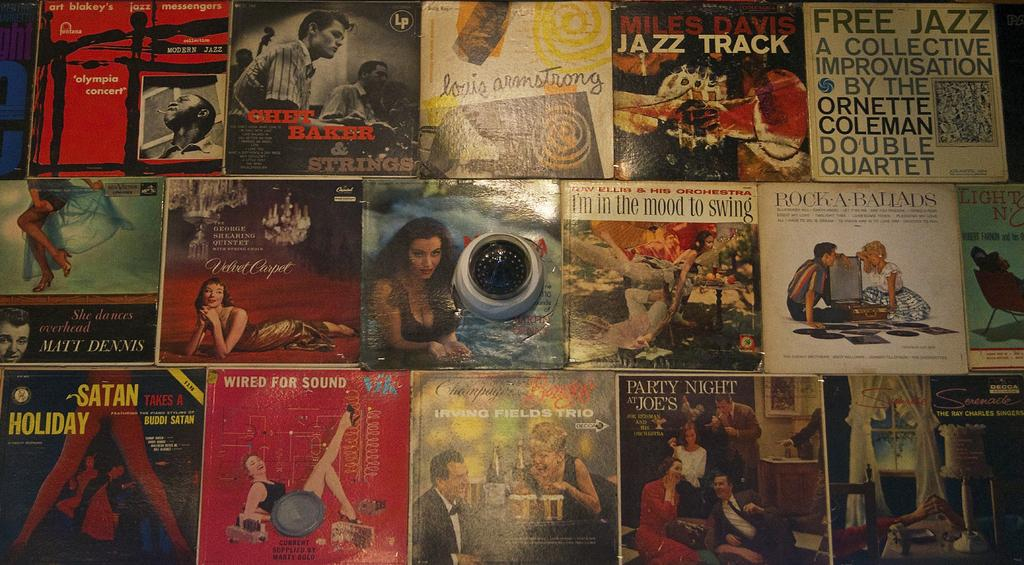<image>
Share a concise interpretation of the image provided. A group of posters, one of which contains the text FREE JAZZ. 